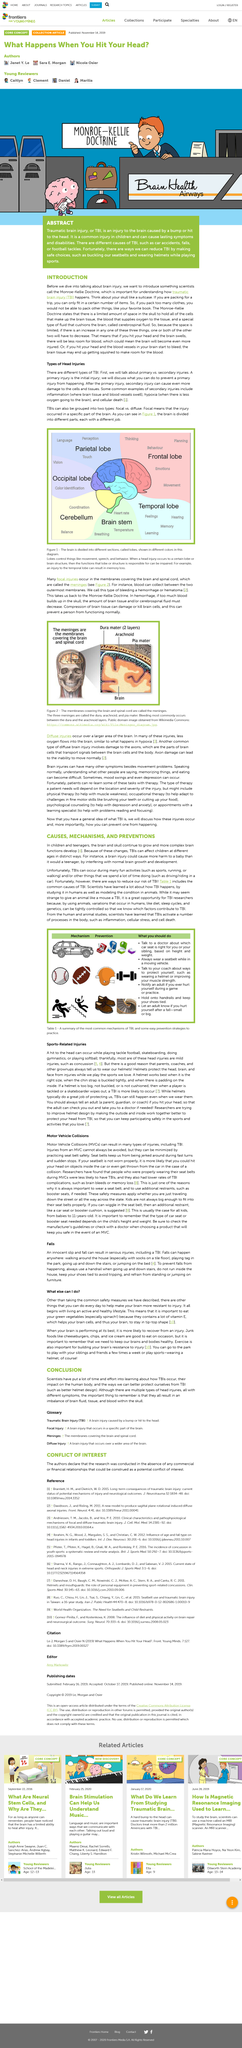Outline some significant characteristics in this image. The temporal lobe is responsible for feelings. It is advisable to utilize a handrail when ascending and descending stairs to ensure safety and prevent accidents. Green vegetables are a rich source of vitamin E, containing a significant amount of this essential nutrient. Traumatic brain injury (TBI) can be grouped into two categories: focal and diffuse. Focal TBI refers to an injury that is localized to a specific part of the brain, while diffuse TBI involves widespread damage to the brain tissue. Traumatic brain injury (TBI) is a type of injury to the brain caused by a bump or hit to the head. This can result in damage to the brain cells and can lead to a range of symptoms, including headaches, memory loss, and changes in behavior. TBI can occur in a variety of settings, including car accidents, sports injuries, and military combat. It is important to seek medical attention immediately if you suspect that you or someone else has suffered a TBI. Early treatment can help to minimize the long-term effects of this type of injury. 